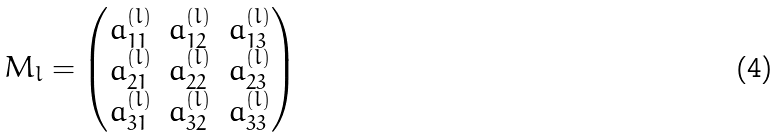<formula> <loc_0><loc_0><loc_500><loc_500>M _ { l } = \begin{pmatrix} a _ { 1 1 } ^ { ( l ) } & a _ { 1 2 } ^ { ( l ) } & a _ { 1 3 } ^ { ( l ) } \\ a _ { 2 1 } ^ { ( l ) } & a _ { 2 2 } ^ { ( l ) } & a _ { 2 3 } ^ { ( l ) } \\ a _ { 3 1 } ^ { ( l ) } & a _ { 3 2 } ^ { ( l ) } & a _ { 3 3 } ^ { ( l ) } \end{pmatrix}</formula> 